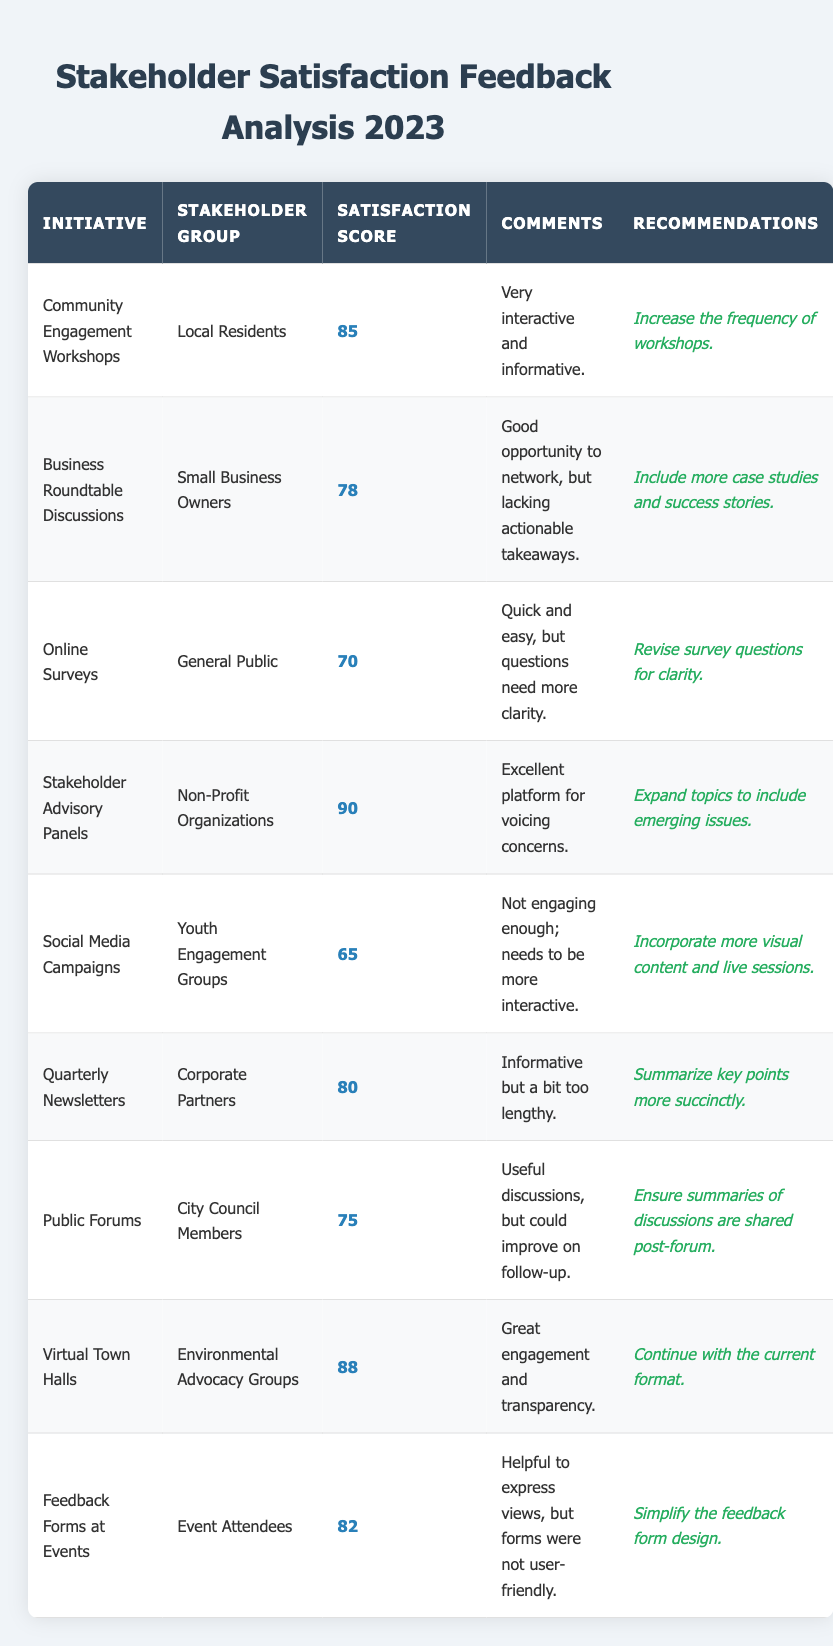What is the satisfaction score for the Community Engagement Workshops? The satisfaction score is specifically listed for each initiative in the table, and for the Community Engagement Workshops, it is 85.
Answer: 85 Which stakeholder group has the highest satisfaction score? By examining the satisfaction scores listed in the table for each stakeholder group, the Non-Profit Organizations have the highest score of 90.
Answer: Non-Profit Organizations How many initiatives received a satisfaction score of 80 or above? Count the number of initiatives with scores 80 or above: Community Engagement Workshops (85), Stakeholder Advisory Panels (90), Virtual Town Halls (88), and Feedback Forms at Events (82). This totals 4 initiatives.
Answer: 4 Is the satisfaction score for Social Media Campaigns higher than that for Online Surveys? The satisfaction score for Social Media Campaigns is 65 and for Online Surveys is 70. Since 65 is less than 70, the statement is false.
Answer: No What is the average satisfaction score across all initiatives? Add all the satisfaction scores together (85 + 78 + 70 + 90 + 65 + 80 + 75 + 88 + 82) which equals 818. Then divide by the total number of initiatives, which is 9. Thus, the average is 818 / 9 = 91.89.
Answer: 91.89 What specific recommendations were given for Business Roundtable Discussions? Under the recommendations column for Business Roundtable Discussions, it is specified to "Include more case studies and success stories."
Answer: Include more case studies and success stories Which initiative had the lowest satisfaction score? By scanning through the satisfaction scores in the table, the initiative with the lowest score is Social Media Campaigns at 65.
Answer: Social Media Campaigns Do any initiatives recommend increasing the frequency of engagement? The recommendations for Community Engagement Workshops suggest "Increase the frequency of workshops." This indicates that there is a recommendation for increasing engagement frequency.
Answer: Yes What is the difference in satisfaction score between the highest and the lowest rated initiatives? The highest satisfaction score is 90 from Stakeholder Advisory Panels and the lowest is 65 from Social Media Campaigns. The difference is calculated as 90 - 65 = 25.
Answer: 25 How many stakeholder groups reported dissatisfaction with their respective initiatives? Dissatisfaction can be interpreted as scores below 70. The only group with such a score is Youth Engagement Groups, with a score of 65. Therefore, only one group reported dissatisfaction.
Answer: 1 